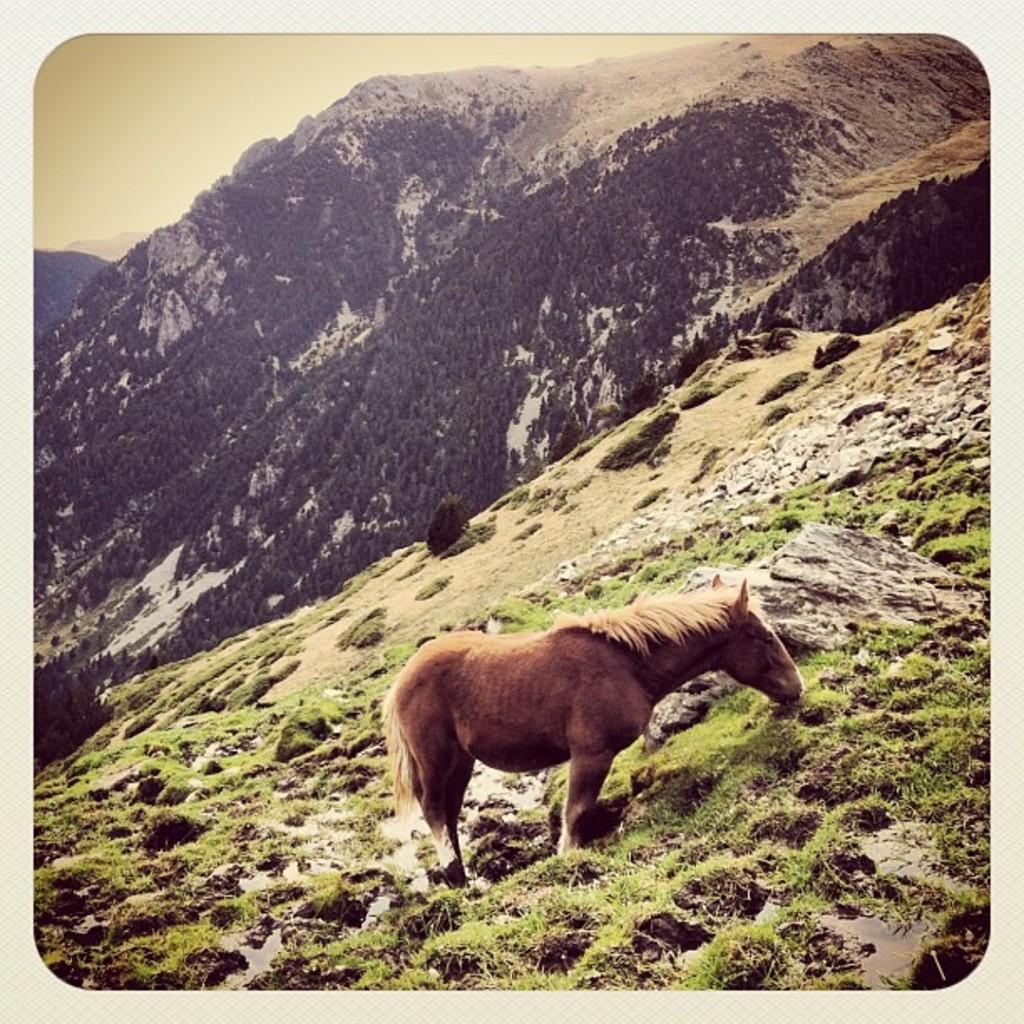How would you summarize this image in a sentence or two? In this picture we can see horse, grass and rocks. In the background of the image we can see hills, trees and sky. 